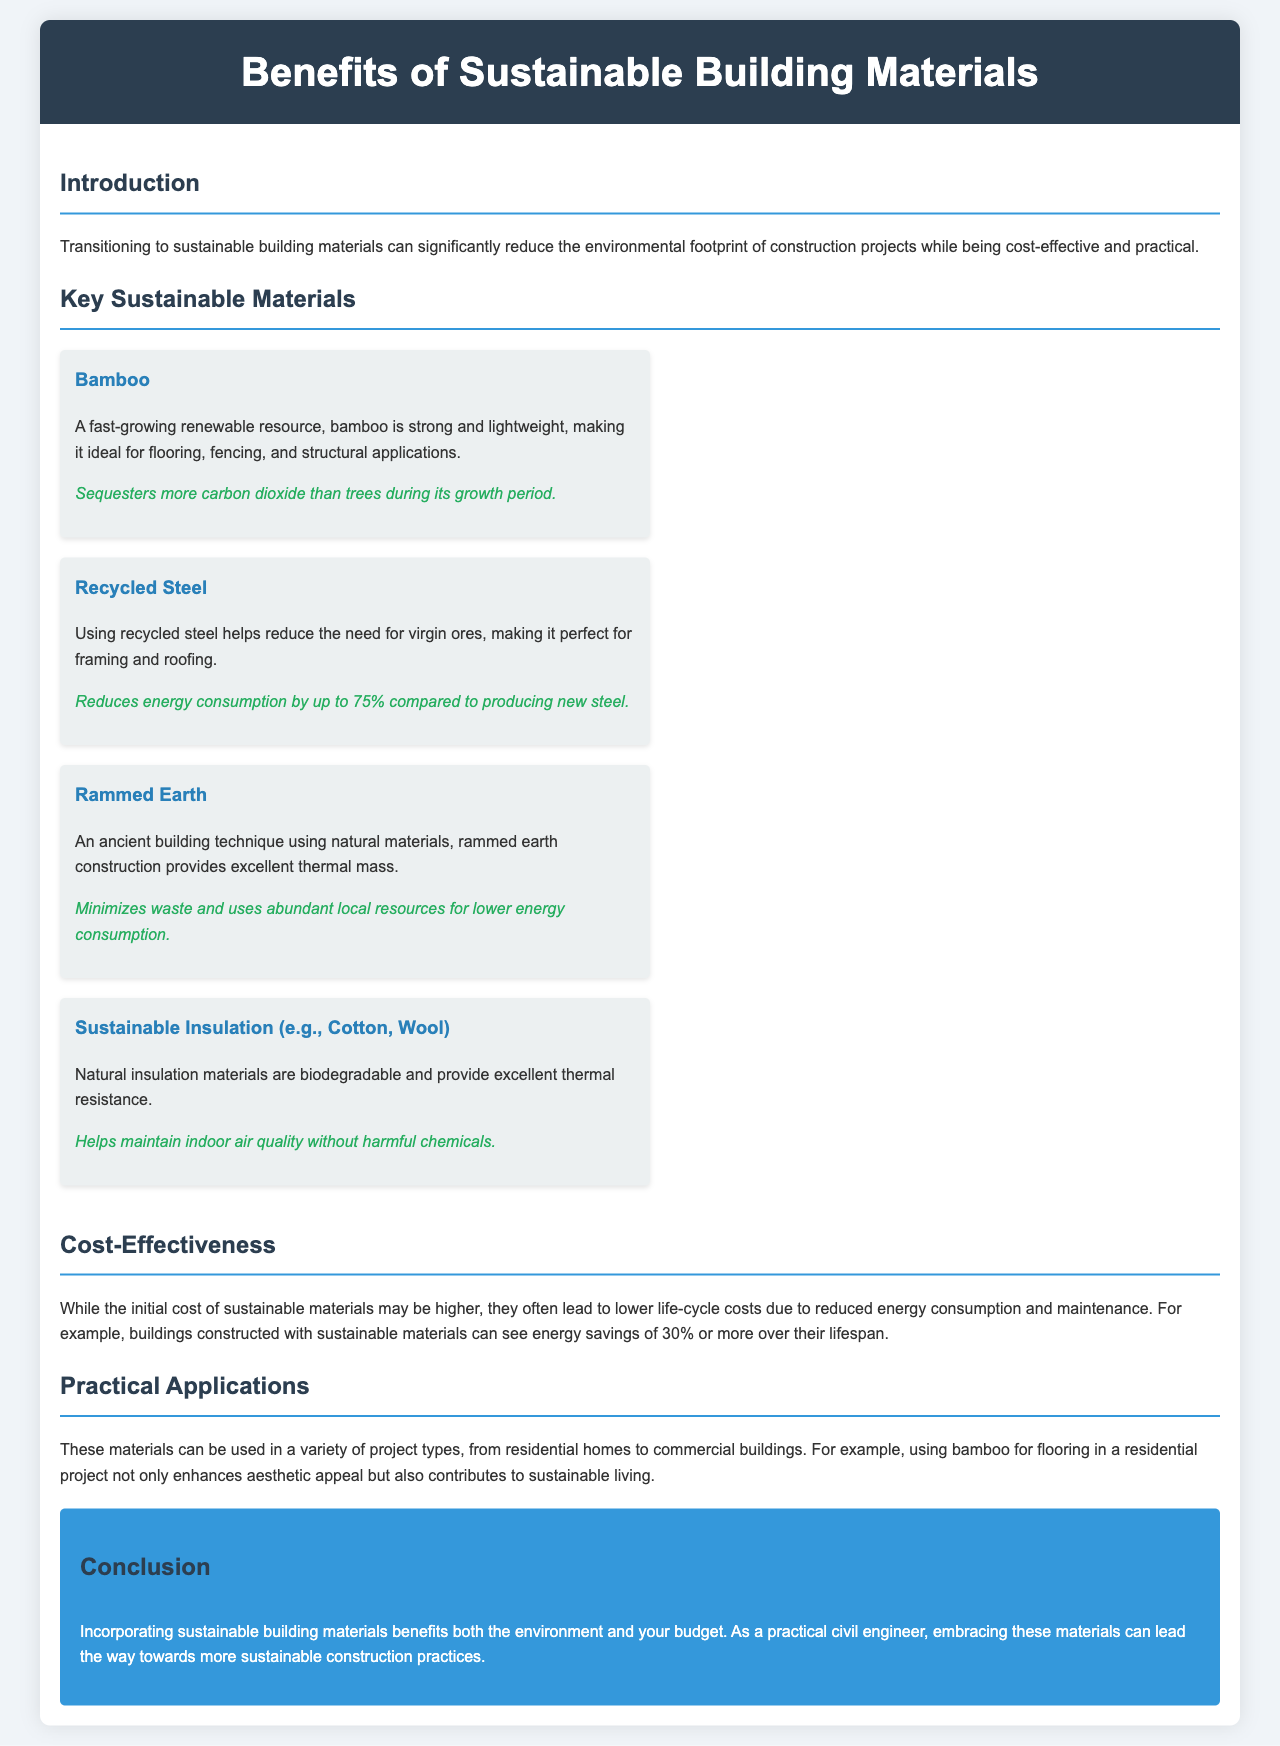What is the main benefit of transitioning to sustainable building materials? The document states that transitioning to sustainable building materials can significantly reduce the environmental footprint of construction projects.
Answer: Reduce environmental footprint Which material sequesters more carbon dioxide during its growth? The document mentions that bamboo sequesters more carbon dioxide than trees during its growth period.
Answer: Bamboo What is a key benefit of using recycled steel? The text highlights that using recycled steel reduces energy consumption by up to 75% compared to producing new steel.
Answer: Reduces energy consumption What percentage of energy savings can buildings with sustainable materials achieve over their lifespan? The document notes that buildings constructed with sustainable materials can see energy savings of 30% or more over their lifespan.
Answer: 30% What type of insulation is mentioned as being biodegradable? The brochure refers to sustainable insulation materials like cotton and wool, which are biodegradable.
Answer: Cotton, Wool Which construction method uses abundant local resources? The document describes rammed earth construction as minimizing waste and using abundant local resources.
Answer: Rammed Earth What is the initial cost comparison for sustainable materials? According to the document, while the initial cost of sustainable materials may be higher, they lead to lower life-cycle costs.
Answer: Higher initial cost In what types of projects can sustainable materials be applied? The document outlines that sustainable materials can be used in various project types, including residential homes and commercial buildings.
Answer: Residential homes, Commercial buildings What is the conclusion of the brochure? The conclusion states that incorporating sustainable building materials benefits both the environment and your budget.
Answer: Benefits both environment and budget 